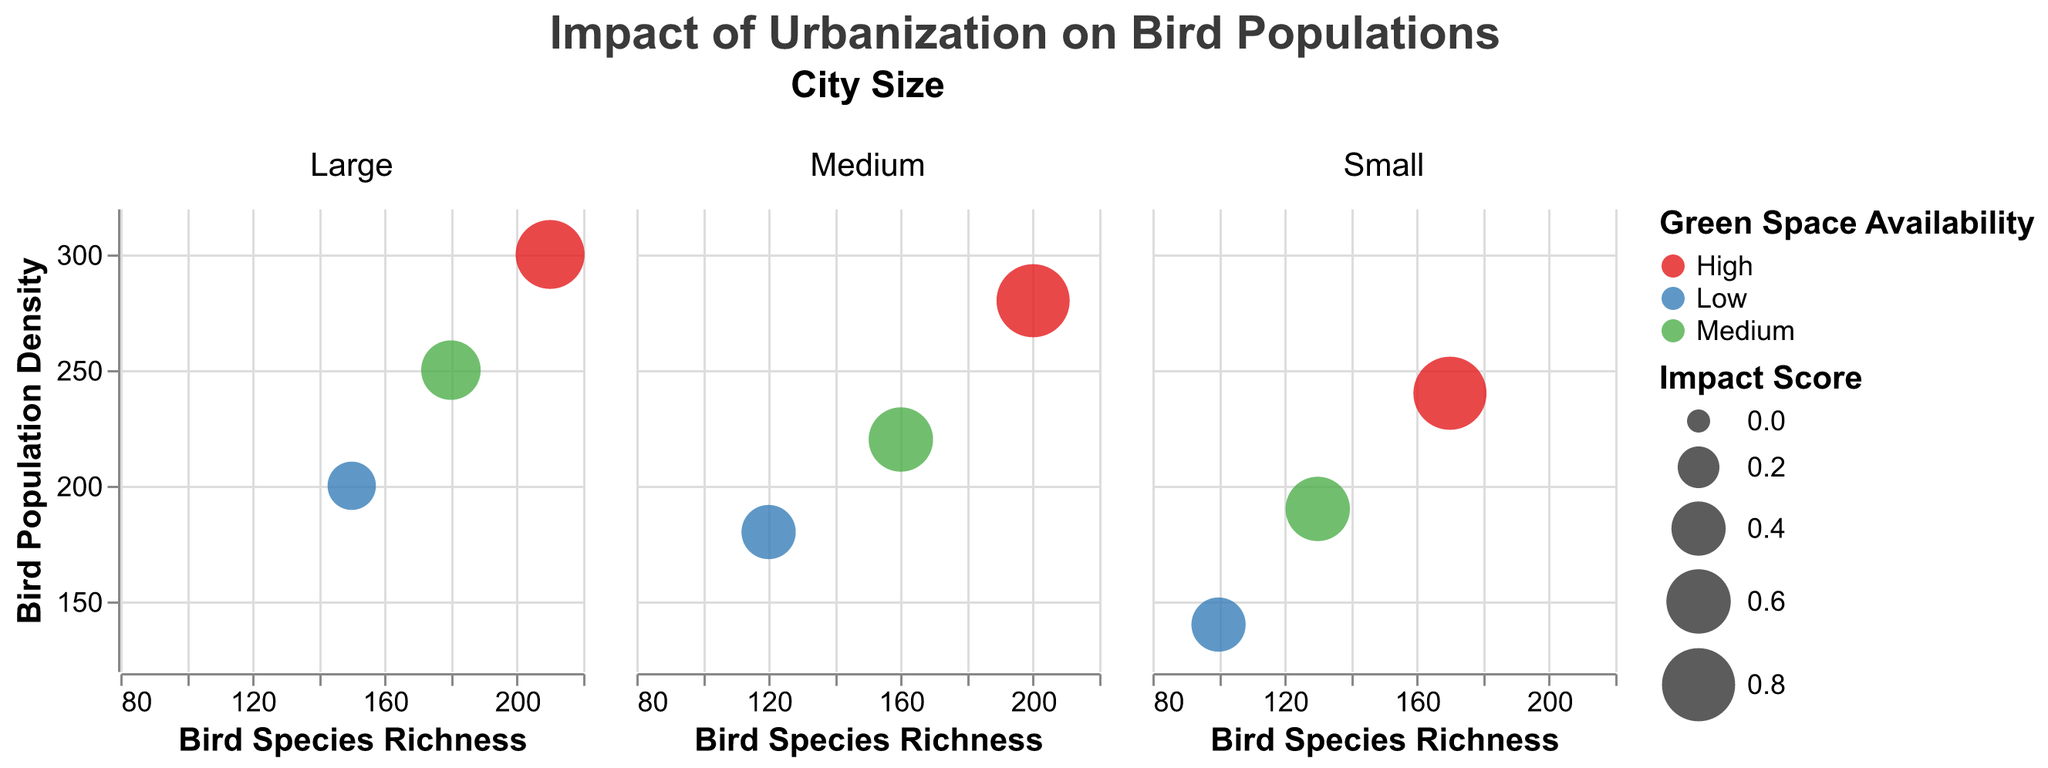How many cities have a high level of green space availability? To find this, look for cities with green space availability classified as "High." From the bubble chart, count the cities under each "City Size" column with "High" green space availability. There are three such cities: Chicago, Portland, and Burlington.
Answer: 3 Which city has the lowest impact score in the 'Large' city size category? To determine this, locate the column for "Large" cities and identify the bubble with the smallest size. The tooltip or the size of the bubble directly indicates the impact score. New York has an impact score of 0.3, which is the lowest in the 'Large' category.
Answer: New York What is the relationship between green space availability and bird species richness in large cities? Compare the bird species richness for the bubbles representing different levels of green space availability within the "Large" city size column. Chicago (High) has the highest species richness of 210, followed by Los Angeles (Medium) with 180, and New York (Low) with 150. This suggests that greater green space availability correlates with higher bird species richness.
Answer: Greater green space correlates with higher species richness Which medium-sized city has the highest bird population density? Check the y-axis values of the bubbles in the "Medium" city size column. The city with the highest y-axis value has the highest bird population density. Portland, with a density of 280, is the highest among medium-sized cities.
Answer: Portland What is the average bird species richness for small cities? Identify the bird species richness values for small cities: Boulder (100), Asheville (130), and Burlington (170). Calculate the average: (100 + 130 + 170) / 3 = 400 / 3 ≈ 133.33
Answer: Approximately 133.33 Compare the impact scores of medium-sized cities with low and high green space availability. For medium-sized cities, locate the impact scores for San Francisco (Low, score 0.4) and Portland (High, score 0.8). Comparing them, Portland has a higher impact score than San Francisco.
Answer: Portland has a higher impact score than San Francisco What are the bird species richness and population density values for the city with the highest impact score? Identify the largest bubble in the chart, representing the highest impact score. This is Portland in the medium city size category, with bird species richness of 200 and population density of 280.
Answer: Richness: 200, Density: 280 Is there a city with a medium level of green space availability and an impact score of 0.6? If so, which one is it? Look for bubbles colored to indicate medium green space availability and an impact score of 0.6. Both Denver (medium city size) and Asheville (small city size) match this description.
Answer: Denver, Asheville 